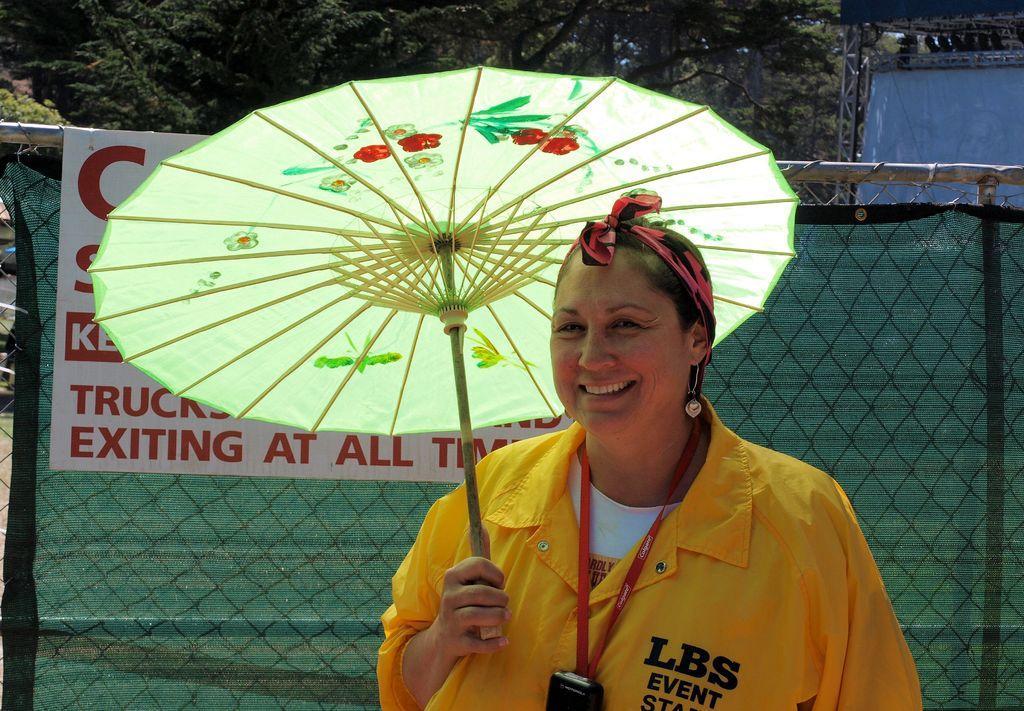How would you summarize this image in a sentence or two? In this image we can see a person wearing yellow color jacket holding umbrella and wearing red color tag to which some electronic gadget is attached and in the background of the image there is fencing and some trees. 